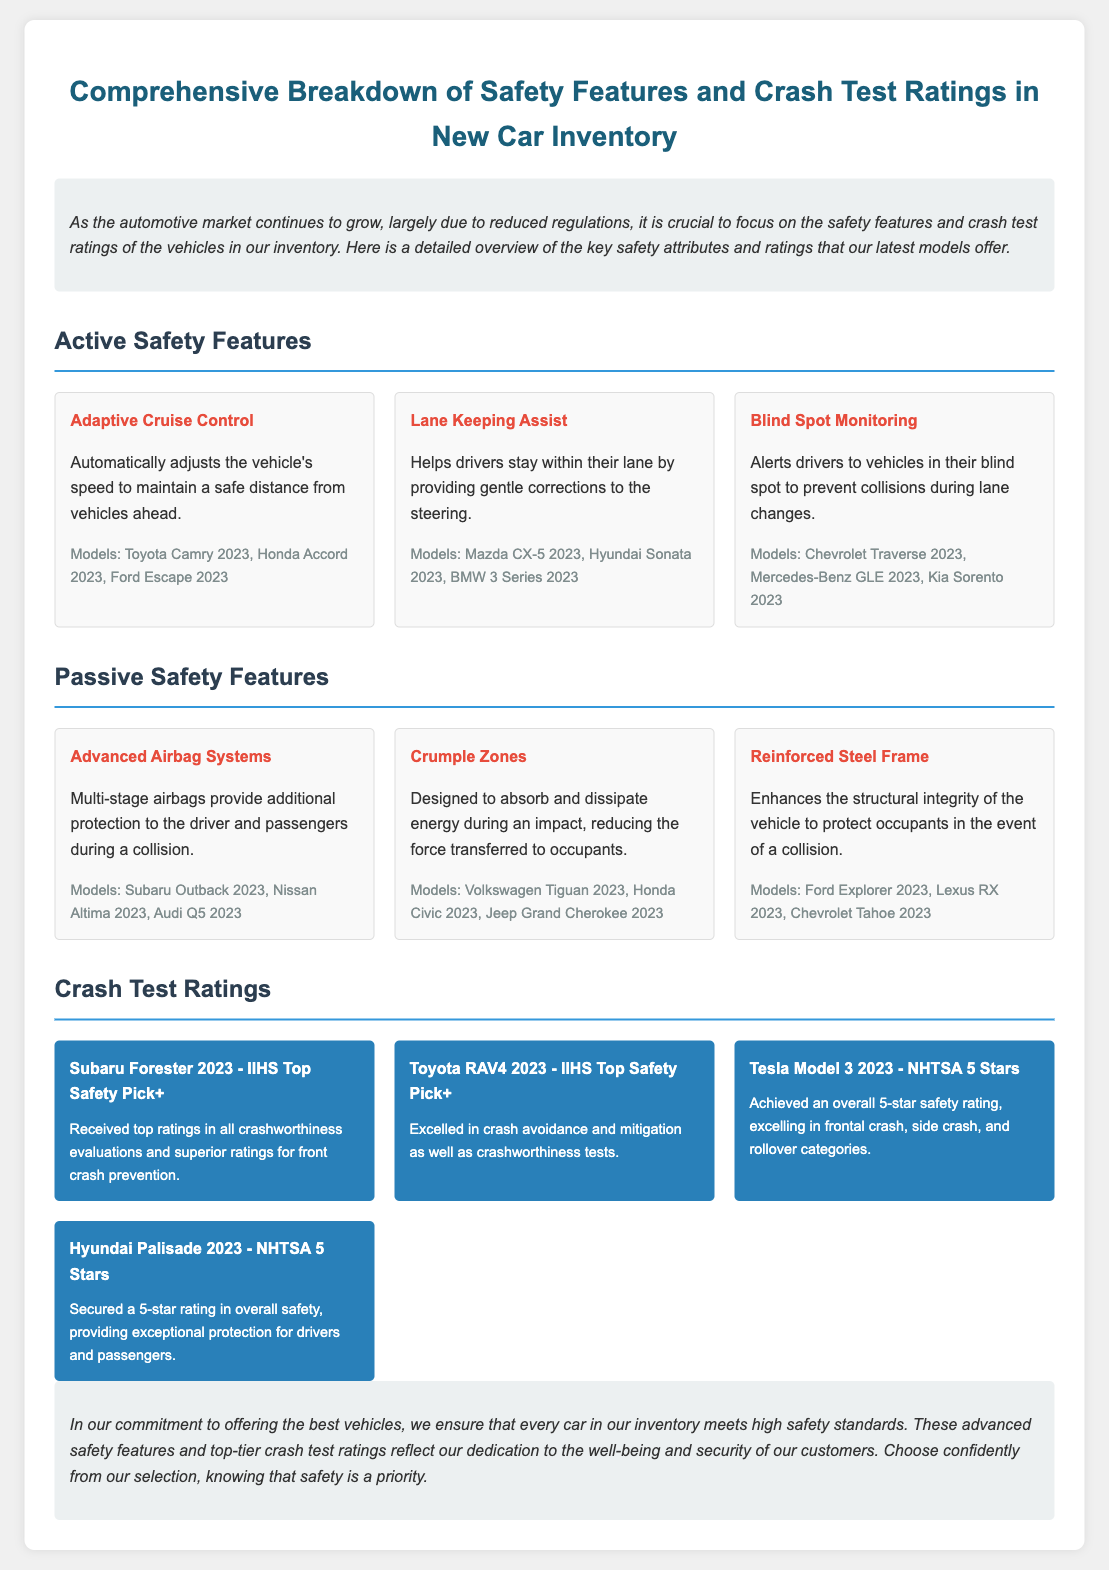what is the title of the document? The title is prominently displayed at the top of the document.
Answer: Comprehensive Breakdown of Safety Features and Crash Test Ratings in New Car Inventory how many active safety features are listed? The document lists several active safety features within the relevant section.
Answer: 3 which model has Lane Keeping Assist? The models using this feature are mentioned alongside its description.
Answer: Mazda CX-5 2023, Hyundai Sonata 2023, BMW 3 Series 2023 what is the crash test rating of the Tesla Model 3 2023? The rating is summarized clearly in the crash test ratings section along with the model name.
Answer: NHTSA 5 Stars which safety feature helps maintain a safe distance from vehicles ahead? The safety feature that performs this function is mentioned explicitly in the features list.
Answer: Adaptive Cruise Control what is one passive safety feature listed in the document? The document outlines several passive safety features in its respective section.
Answer: Advanced Airbag Systems how many crash test ratings include a mention of the IIHS Top Safety Pick+? The IIHS Top Safety Pick+ rating is included in the crash test ratings section for specific models.
Answer: 2 which vehicle received a superior rating for front crash prevention? This detail is indicated within the description associated with a specific model in the crash test ratings.
Answer: Subaru Forester 2023 what is the primary purpose of the crumple zones? The purpose is clearly stated in the document concerning occupant safety during impacts.
Answer: Absorb and dissipate energy during an impact 